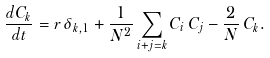Convert formula to latex. <formula><loc_0><loc_0><loc_500><loc_500>\frac { d C _ { k } } { d t } = r \, \delta _ { k , 1 } + \frac { 1 } { N ^ { 2 } } \sum _ { i + j = k } C _ { i } \, C _ { j } - \frac { 2 } { N } \, C _ { k } .</formula> 